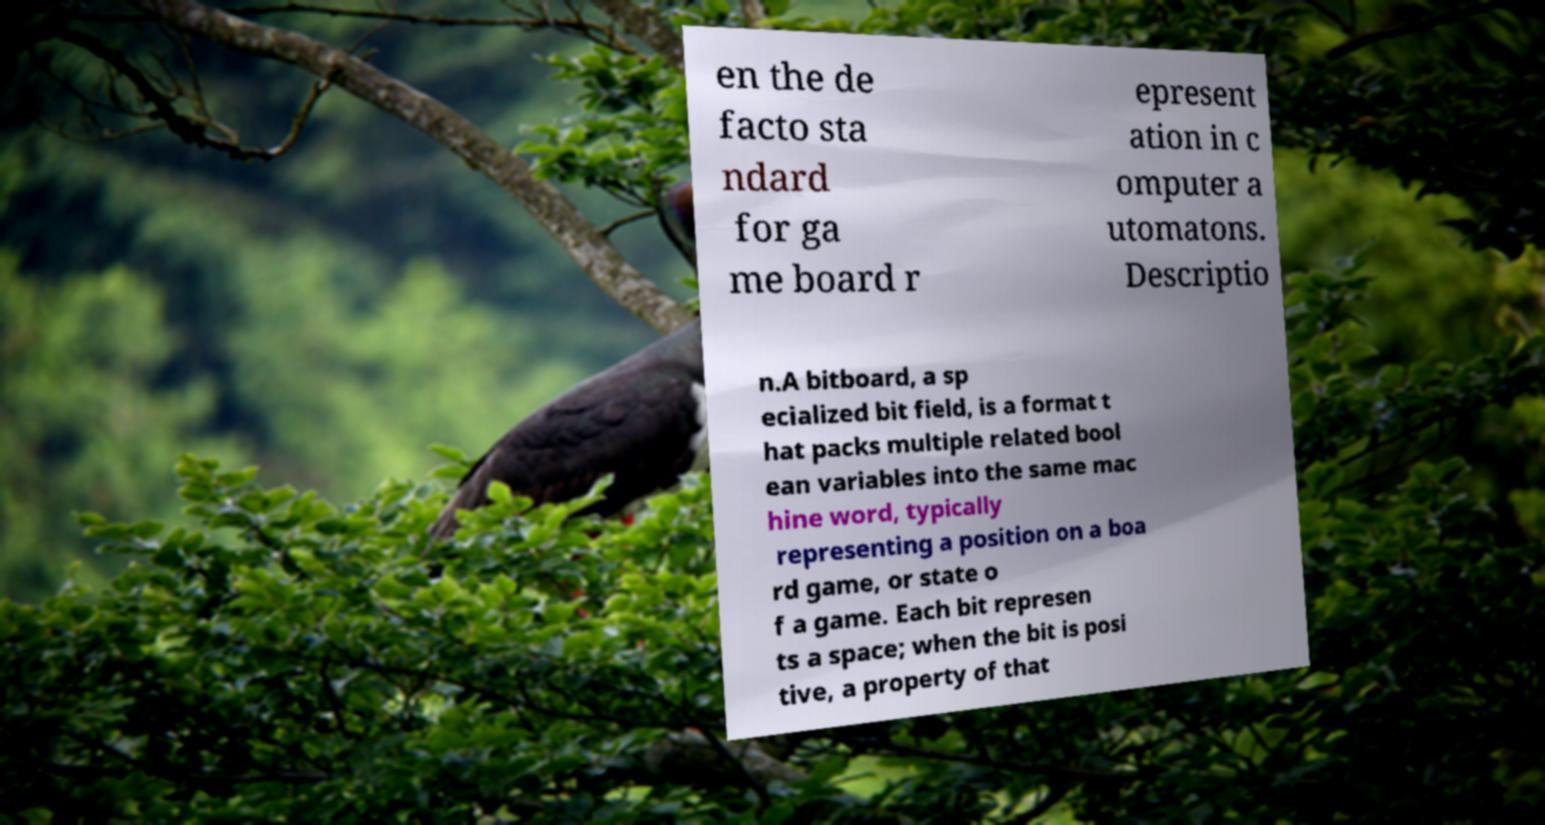Can you read and provide the text displayed in the image?This photo seems to have some interesting text. Can you extract and type it out for me? en the de facto sta ndard for ga me board r epresent ation in c omputer a utomatons. Descriptio n.A bitboard, a sp ecialized bit field, is a format t hat packs multiple related bool ean variables into the same mac hine word, typically representing a position on a boa rd game, or state o f a game. Each bit represen ts a space; when the bit is posi tive, a property of that 